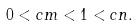Convert formula to latex. <formula><loc_0><loc_0><loc_500><loc_500>0 < c m < 1 < c n .</formula> 